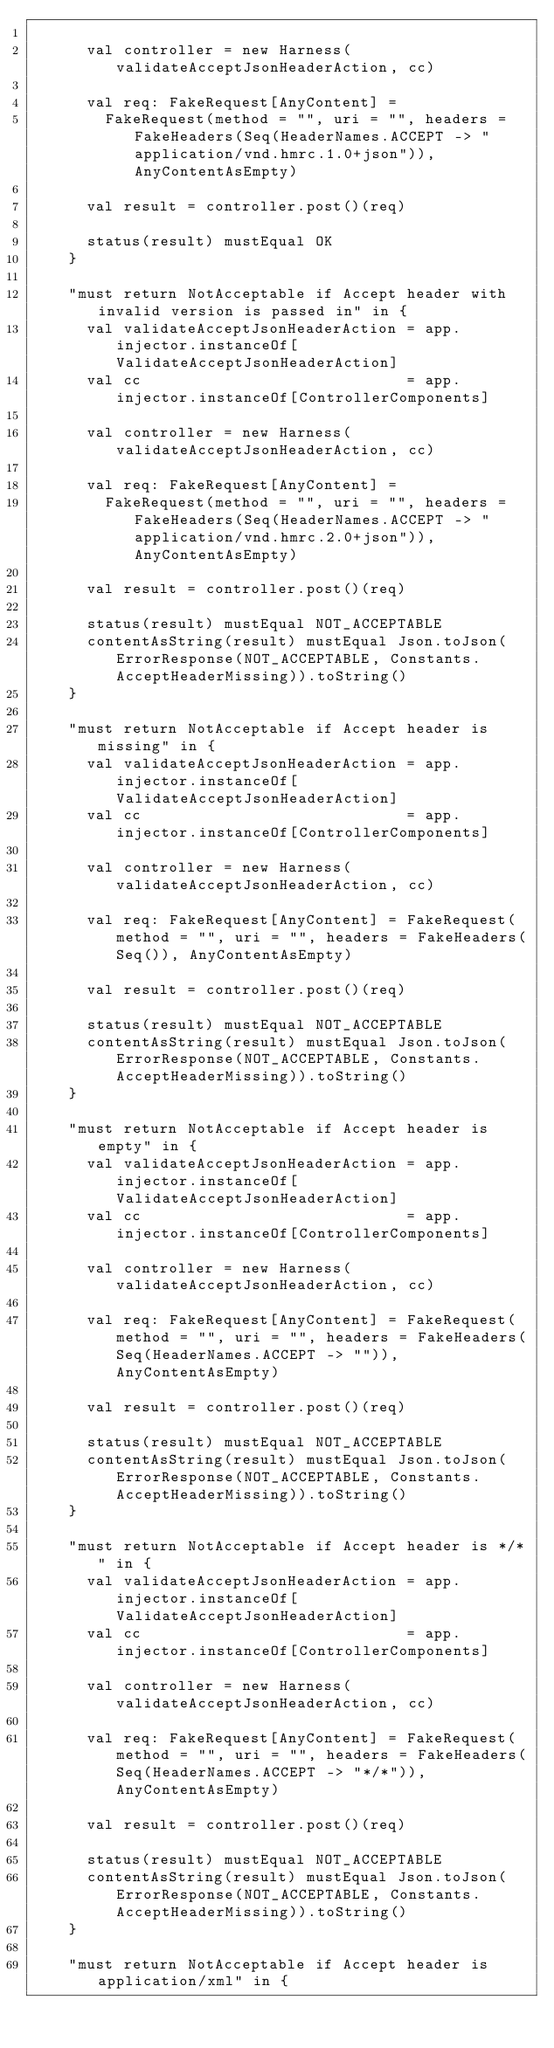Convert code to text. <code><loc_0><loc_0><loc_500><loc_500><_Scala_>
      val controller = new Harness(validateAcceptJsonHeaderAction, cc)

      val req: FakeRequest[AnyContent] =
        FakeRequest(method = "", uri = "", headers = FakeHeaders(Seq(HeaderNames.ACCEPT -> "application/vnd.hmrc.1.0+json")), AnyContentAsEmpty)

      val result = controller.post()(req)

      status(result) mustEqual OK
    }

    "must return NotAcceptable if Accept header with invalid version is passed in" in {
      val validateAcceptJsonHeaderAction = app.injector.instanceOf[ValidateAcceptJsonHeaderAction]
      val cc                             = app.injector.instanceOf[ControllerComponents]

      val controller = new Harness(validateAcceptJsonHeaderAction, cc)

      val req: FakeRequest[AnyContent] =
        FakeRequest(method = "", uri = "", headers = FakeHeaders(Seq(HeaderNames.ACCEPT -> "application/vnd.hmrc.2.0+json")), AnyContentAsEmpty)

      val result = controller.post()(req)

      status(result) mustEqual NOT_ACCEPTABLE
      contentAsString(result) mustEqual Json.toJson(ErrorResponse(NOT_ACCEPTABLE, Constants.AcceptHeaderMissing)).toString()
    }

    "must return NotAcceptable if Accept header is missing" in {
      val validateAcceptJsonHeaderAction = app.injector.instanceOf[ValidateAcceptJsonHeaderAction]
      val cc                             = app.injector.instanceOf[ControllerComponents]

      val controller = new Harness(validateAcceptJsonHeaderAction, cc)

      val req: FakeRequest[AnyContent] = FakeRequest(method = "", uri = "", headers = FakeHeaders(Seq()), AnyContentAsEmpty)

      val result = controller.post()(req)

      status(result) mustEqual NOT_ACCEPTABLE
      contentAsString(result) mustEqual Json.toJson(ErrorResponse(NOT_ACCEPTABLE, Constants.AcceptHeaderMissing)).toString()
    }

    "must return NotAcceptable if Accept header is empty" in {
      val validateAcceptJsonHeaderAction = app.injector.instanceOf[ValidateAcceptJsonHeaderAction]
      val cc                             = app.injector.instanceOf[ControllerComponents]

      val controller = new Harness(validateAcceptJsonHeaderAction, cc)

      val req: FakeRequest[AnyContent] = FakeRequest(method = "", uri = "", headers = FakeHeaders(Seq(HeaderNames.ACCEPT -> "")), AnyContentAsEmpty)

      val result = controller.post()(req)

      status(result) mustEqual NOT_ACCEPTABLE
      contentAsString(result) mustEqual Json.toJson(ErrorResponse(NOT_ACCEPTABLE, Constants.AcceptHeaderMissing)).toString()
    }

    "must return NotAcceptable if Accept header is */*" in {
      val validateAcceptJsonHeaderAction = app.injector.instanceOf[ValidateAcceptJsonHeaderAction]
      val cc                             = app.injector.instanceOf[ControllerComponents]

      val controller = new Harness(validateAcceptJsonHeaderAction, cc)

      val req: FakeRequest[AnyContent] = FakeRequest(method = "", uri = "", headers = FakeHeaders(Seq(HeaderNames.ACCEPT -> "*/*")), AnyContentAsEmpty)

      val result = controller.post()(req)

      status(result) mustEqual NOT_ACCEPTABLE
      contentAsString(result) mustEqual Json.toJson(ErrorResponse(NOT_ACCEPTABLE, Constants.AcceptHeaderMissing)).toString()
    }

    "must return NotAcceptable if Accept header is application/xml" in {</code> 